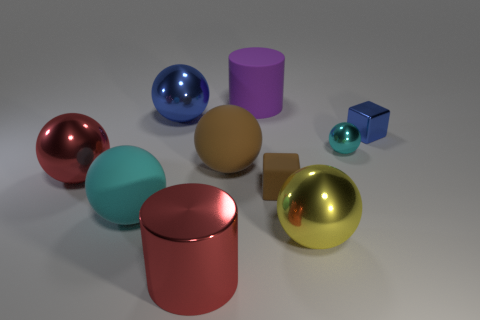What size is the other ball that is the same color as the tiny metallic sphere?
Give a very brief answer. Large. What shape is the metal object that is the same color as the shiny cylinder?
Keep it short and to the point. Sphere. There is a cylinder that is behind the small ball; is its size the same as the cyan object that is on the left side of the large shiny cylinder?
Give a very brief answer. Yes. Are there the same number of cyan rubber objects that are on the right side of the yellow metallic ball and small brown objects on the left side of the big cyan object?
Keep it short and to the point. Yes. There is a red ball; does it have the same size as the blue metal object that is to the left of the tiny cyan ball?
Offer a terse response. Yes. Is there a yellow metallic thing behind the matte sphere that is to the right of the blue metallic sphere?
Your answer should be compact. No. Is there a cyan rubber thing of the same shape as the big yellow metal object?
Your response must be concise. Yes. There is a metallic thing left of the big metallic thing behind the red metallic sphere; how many large metallic balls are right of it?
Offer a very short reply. 2. Does the small matte thing have the same color as the cylinder to the right of the large brown thing?
Offer a terse response. No. What number of objects are either blue objects that are on the right side of the purple rubber cylinder or blue objects that are to the right of the tiny cyan metal object?
Make the answer very short. 1. 